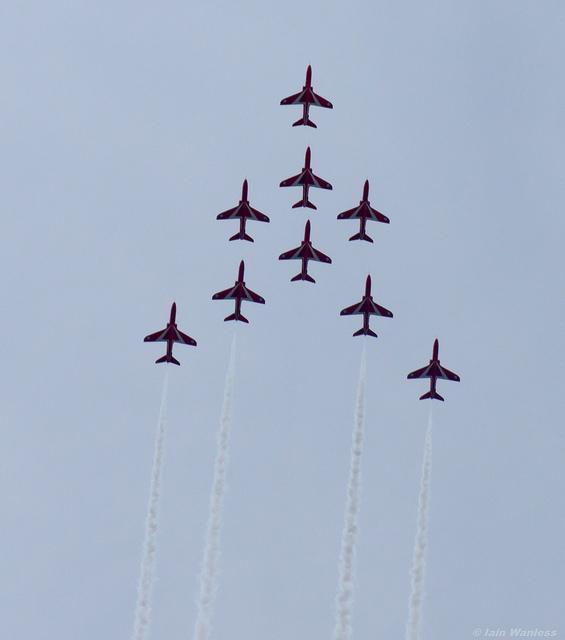How many jets are there?
Give a very brief answer. 9. 